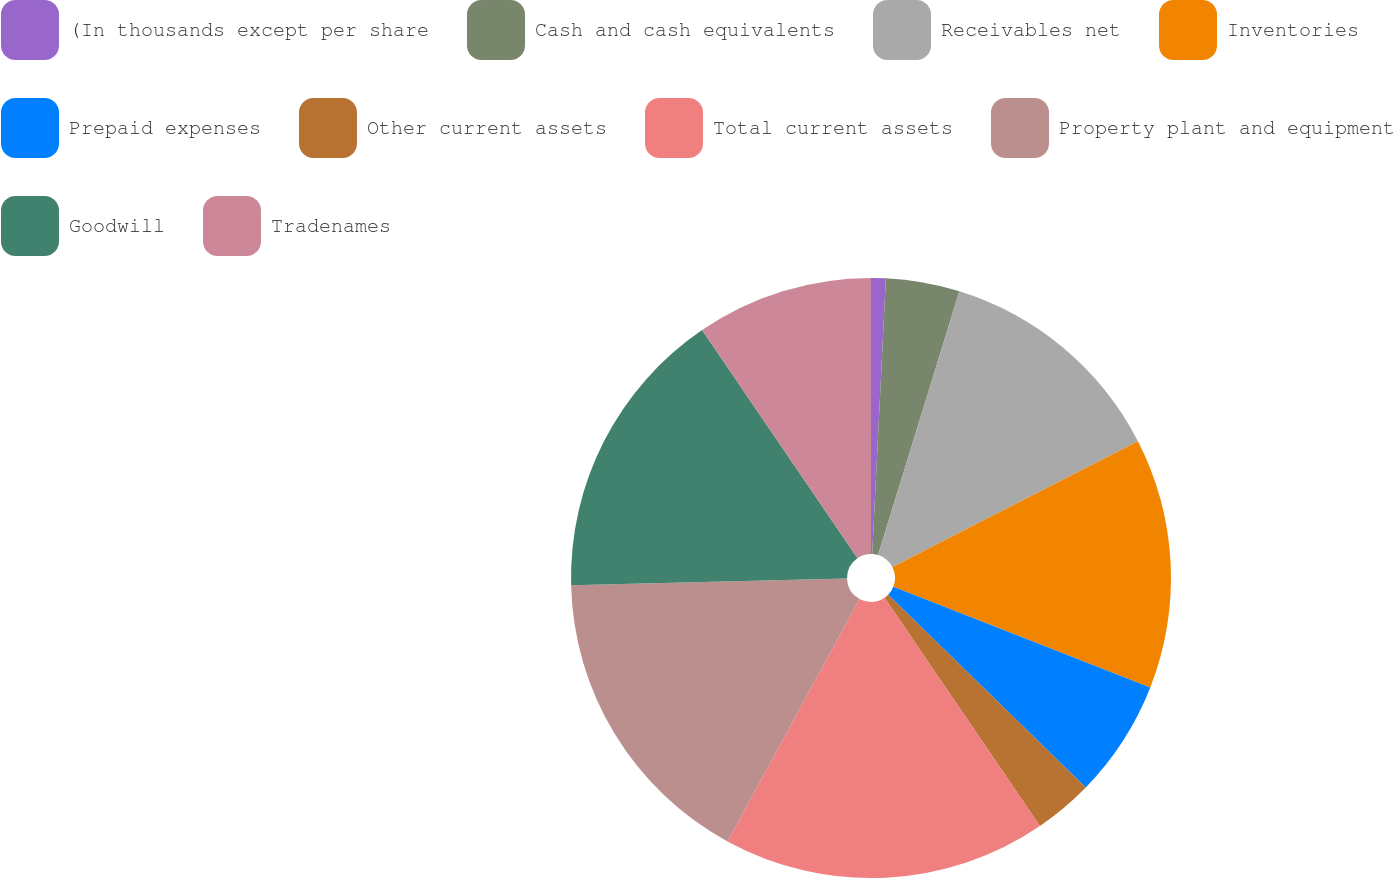<chart> <loc_0><loc_0><loc_500><loc_500><pie_chart><fcel>(In thousands except per share<fcel>Cash and cash equivalents<fcel>Receivables net<fcel>Inventories<fcel>Prepaid expenses<fcel>Other current assets<fcel>Total current assets<fcel>Property plant and equipment<fcel>Goodwill<fcel>Tradenames<nl><fcel>0.79%<fcel>3.97%<fcel>12.7%<fcel>13.49%<fcel>6.35%<fcel>3.18%<fcel>17.46%<fcel>16.67%<fcel>15.87%<fcel>9.52%<nl></chart> 